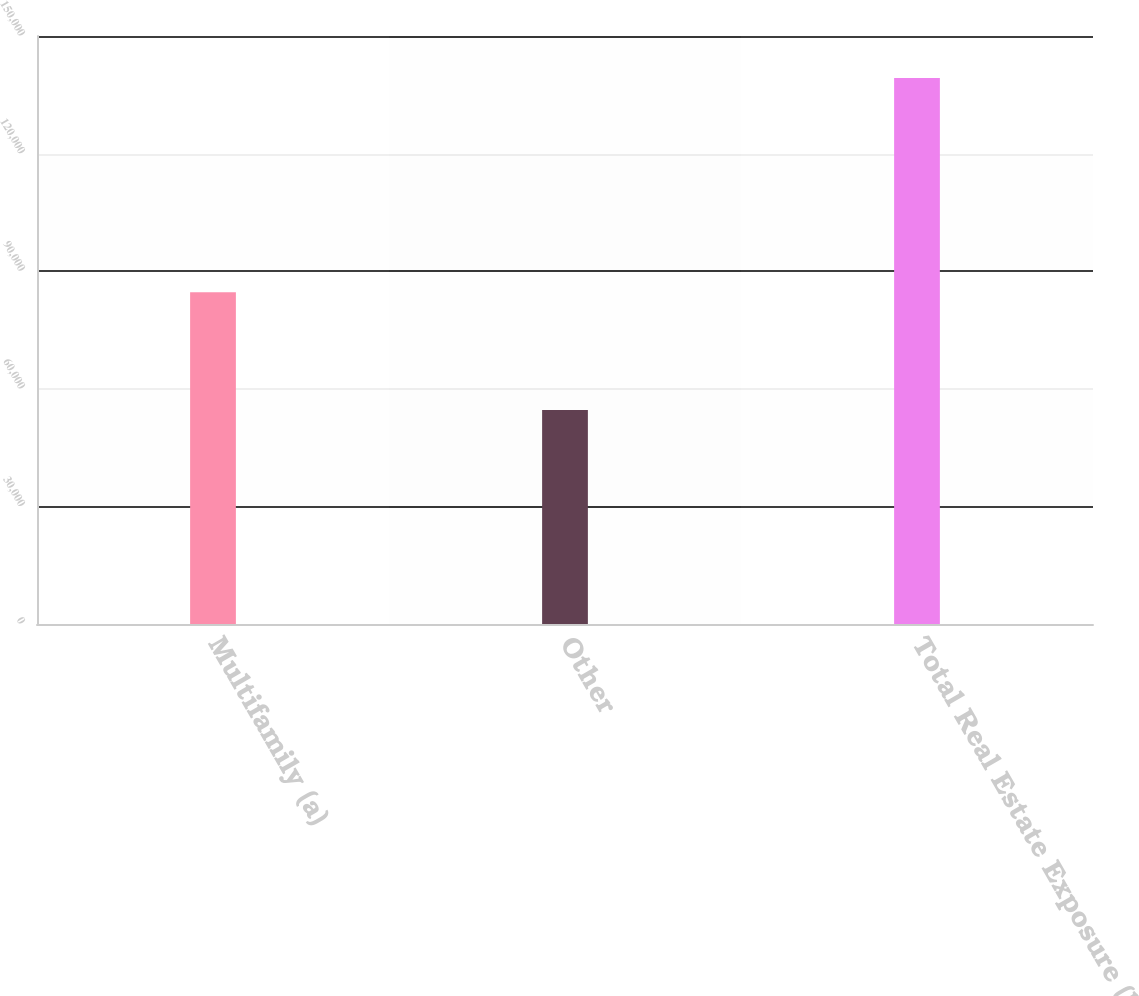Convert chart to OTSL. <chart><loc_0><loc_0><loc_500><loc_500><bar_chart><fcel>Multifamily (a)<fcel>Other<fcel>Total Real Estate Exposure (b)<nl><fcel>84635<fcel>54620<fcel>139255<nl></chart> 